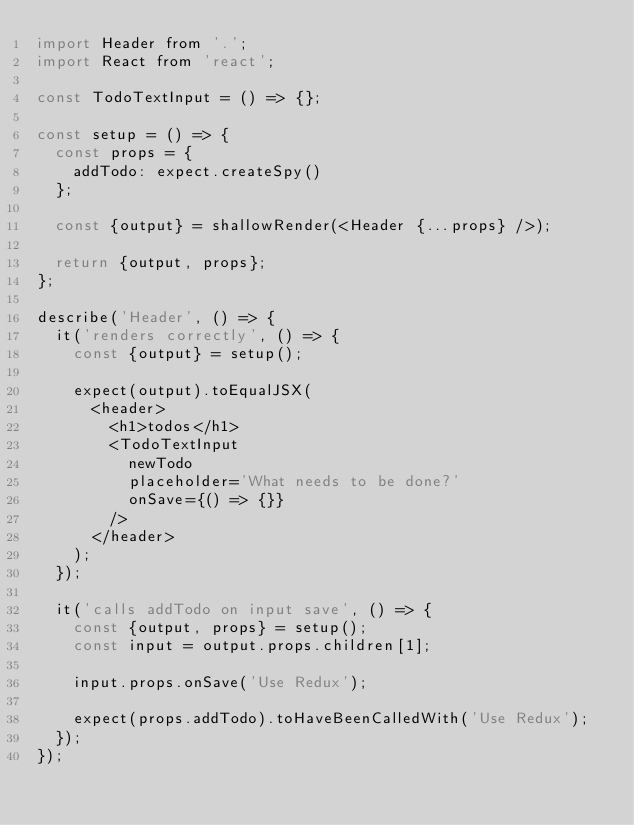Convert code to text. <code><loc_0><loc_0><loc_500><loc_500><_JavaScript_>import Header from '.';
import React from 'react';

const TodoTextInput = () => {};

const setup = () => {
  const props = {
    addTodo: expect.createSpy()
  };

  const {output} = shallowRender(<Header {...props} />);

  return {output, props};
};

describe('Header', () => {
  it('renders correctly', () => {
    const {output} = setup();

    expect(output).toEqualJSX(
      <header>
        <h1>todos</h1>
        <TodoTextInput
          newTodo
          placeholder='What needs to be done?'
          onSave={() => {}}
        />
      </header>
    );
  });

  it('calls addTodo on input save', () => {
    const {output, props} = setup();
    const input = output.props.children[1];

    input.props.onSave('Use Redux');

    expect(props.addTodo).toHaveBeenCalledWith('Use Redux');
  });
});
</code> 